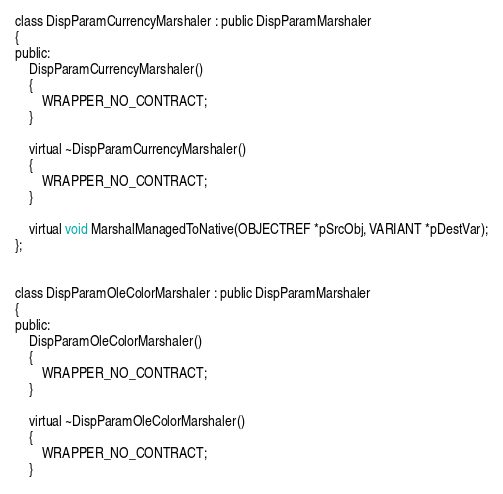Convert code to text. <code><loc_0><loc_0><loc_500><loc_500><_C_>
class DispParamCurrencyMarshaler : public DispParamMarshaler
{
public:
    DispParamCurrencyMarshaler()
    {
        WRAPPER_NO_CONTRACT;
    }

    virtual ~DispParamCurrencyMarshaler()
    {
        WRAPPER_NO_CONTRACT;
    }

    virtual void MarshalManagedToNative(OBJECTREF *pSrcObj, VARIANT *pDestVar);
};


class DispParamOleColorMarshaler : public DispParamMarshaler
{
public:
    DispParamOleColorMarshaler()
    {
        WRAPPER_NO_CONTRACT;
    }

    virtual ~DispParamOleColorMarshaler()
    {
        WRAPPER_NO_CONTRACT;
    }
</code> 